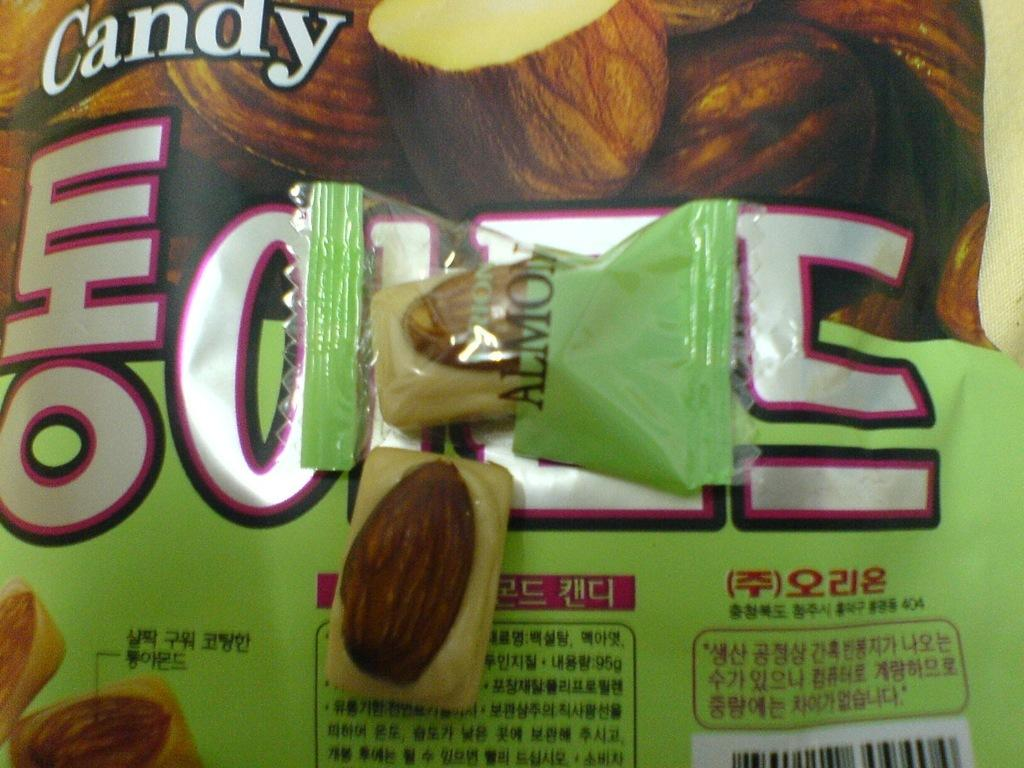What is the main object in the image? There is a cover in the image. What can be seen on the cover? The cover has pictures on it. Is there any writing on the cover? Yes, there is text written on the cover. Where is the boy using the rake in the image? There is no boy or rake present in the image; it only features a cover with pictures and text. What type of pencil is being used to write on the cover in the image? There is no pencil visible in the image, and the text appears to be printed rather than handwritten. 